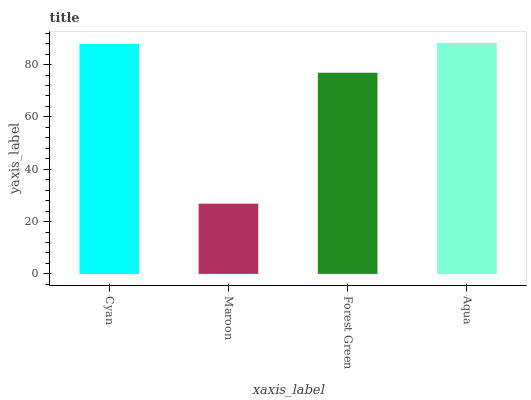Is Maroon the minimum?
Answer yes or no. Yes. Is Aqua the maximum?
Answer yes or no. Yes. Is Forest Green the minimum?
Answer yes or no. No. Is Forest Green the maximum?
Answer yes or no. No. Is Forest Green greater than Maroon?
Answer yes or no. Yes. Is Maroon less than Forest Green?
Answer yes or no. Yes. Is Maroon greater than Forest Green?
Answer yes or no. No. Is Forest Green less than Maroon?
Answer yes or no. No. Is Cyan the high median?
Answer yes or no. Yes. Is Forest Green the low median?
Answer yes or no. Yes. Is Forest Green the high median?
Answer yes or no. No. Is Aqua the low median?
Answer yes or no. No. 